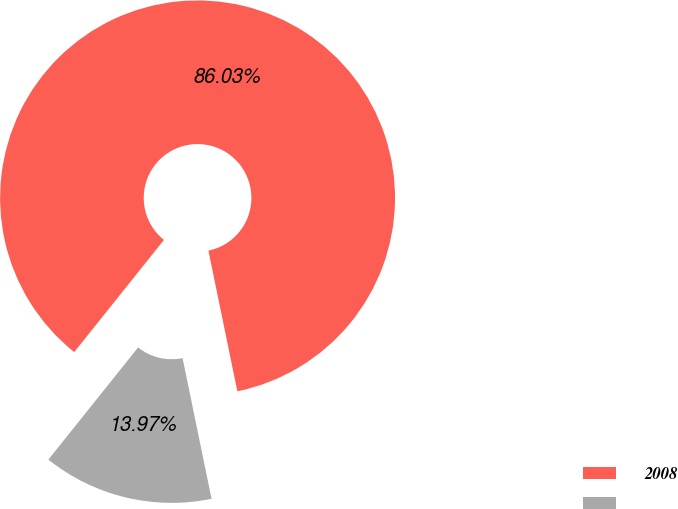<chart> <loc_0><loc_0><loc_500><loc_500><pie_chart><fcel>2008<fcel>Unnamed: 1<nl><fcel>86.03%<fcel>13.97%<nl></chart> 